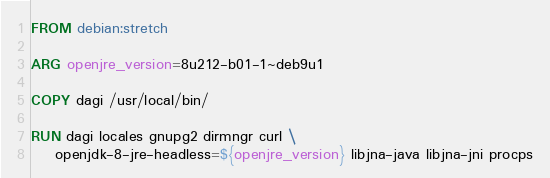<code> <loc_0><loc_0><loc_500><loc_500><_Dockerfile_>FROM debian:stretch

ARG openjre_version=8u212-b01-1~deb9u1

COPY dagi /usr/local/bin/

RUN dagi locales gnupg2 dirmngr curl \
    openjdk-8-jre-headless=${openjre_version} libjna-java libjna-jni procps
</code> 